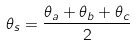Convert formula to latex. <formula><loc_0><loc_0><loc_500><loc_500>\theta _ { s } = \frac { \theta _ { a } + \theta _ { b } + \theta _ { c } } { 2 }</formula> 